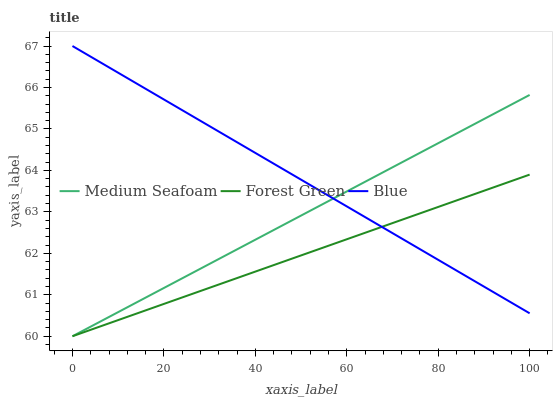Does Forest Green have the minimum area under the curve?
Answer yes or no. Yes. Does Blue have the maximum area under the curve?
Answer yes or no. Yes. Does Medium Seafoam have the minimum area under the curve?
Answer yes or no. No. Does Medium Seafoam have the maximum area under the curve?
Answer yes or no. No. Is Forest Green the smoothest?
Answer yes or no. Yes. Is Blue the roughest?
Answer yes or no. Yes. Is Medium Seafoam the smoothest?
Answer yes or no. No. Is Medium Seafoam the roughest?
Answer yes or no. No. Does Forest Green have the lowest value?
Answer yes or no. Yes. Does Blue have the highest value?
Answer yes or no. Yes. Does Medium Seafoam have the highest value?
Answer yes or no. No. Does Medium Seafoam intersect Blue?
Answer yes or no. Yes. Is Medium Seafoam less than Blue?
Answer yes or no. No. Is Medium Seafoam greater than Blue?
Answer yes or no. No. 